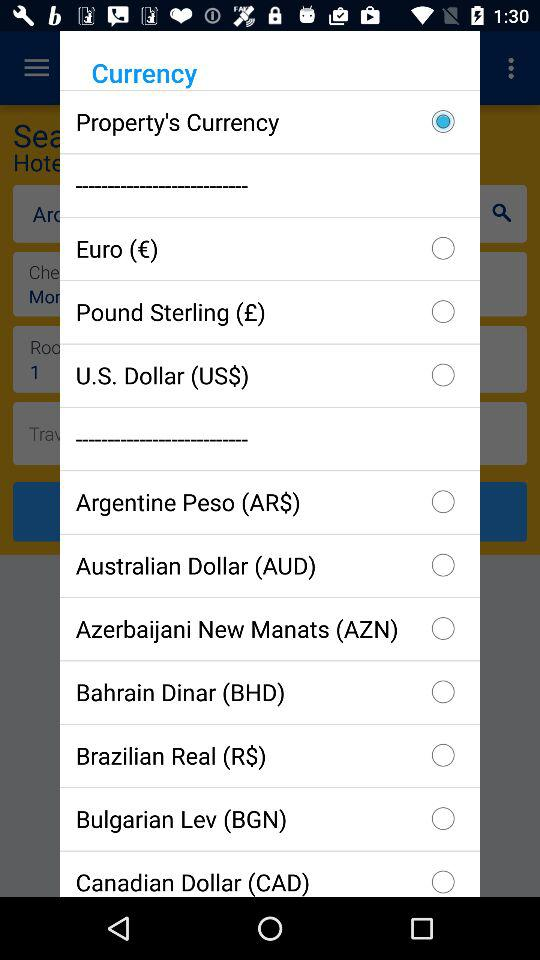Which currency is selected? The selected currency is "Property's Currency". 